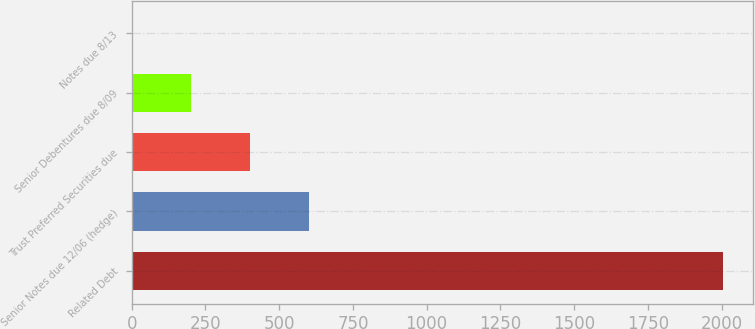<chart> <loc_0><loc_0><loc_500><loc_500><bar_chart><fcel>Related Debt<fcel>Senior Notes due 12/06 (hedge)<fcel>Trust Preferred Securities due<fcel>Senior Debentures due 8/09<fcel>Notes due 8/13<nl><fcel>2006<fcel>602.73<fcel>402.26<fcel>201.79<fcel>1.32<nl></chart> 